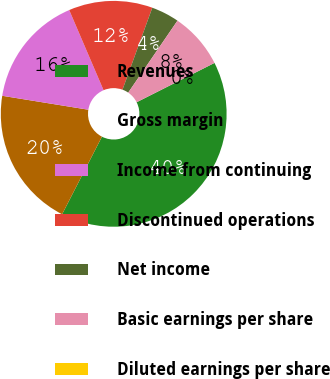<chart> <loc_0><loc_0><loc_500><loc_500><pie_chart><fcel>Revenues<fcel>Gross margin<fcel>Income from continuing<fcel>Discontinued operations<fcel>Net income<fcel>Basic earnings per share<fcel>Diluted earnings per share<nl><fcel>39.99%<fcel>20.0%<fcel>16.0%<fcel>12.0%<fcel>4.0%<fcel>8.0%<fcel>0.0%<nl></chart> 